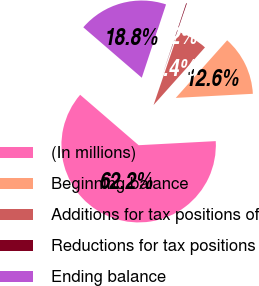Convert chart. <chart><loc_0><loc_0><loc_500><loc_500><pie_chart><fcel>(In millions)<fcel>Beginning balance<fcel>Additions for tax positions of<fcel>Reductions for tax positions<fcel>Ending balance<nl><fcel>62.17%<fcel>12.56%<fcel>6.36%<fcel>0.15%<fcel>18.76%<nl></chart> 